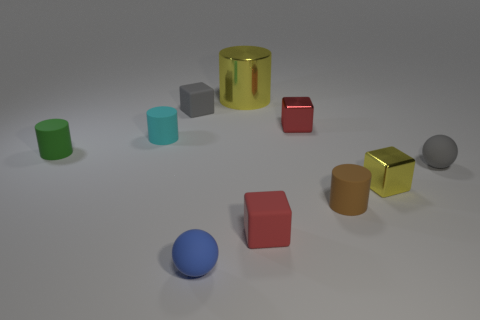How many other things are there of the same color as the shiny cylinder? Upon examining the image, there is one other object that shares the same golden hue as the shiny cylinder: a cube with similar reflective properties. It's quite fascinating to see how objects of the same color can differ in shape yet still be part of a cohesive visual theme. 